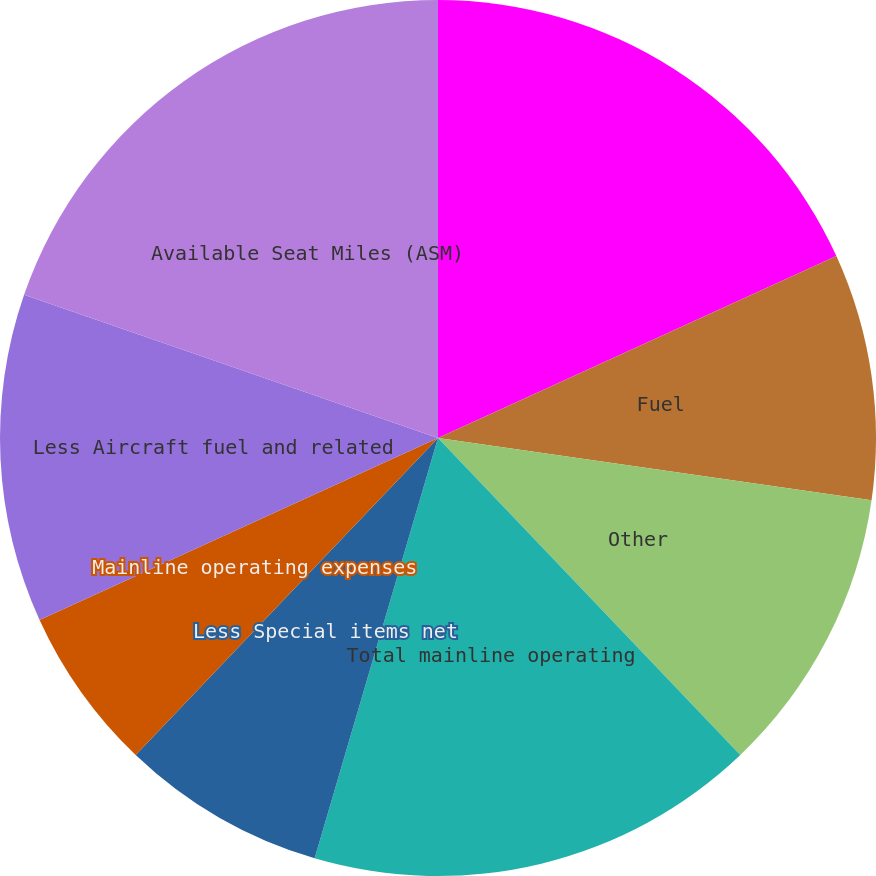Convert chart. <chart><loc_0><loc_0><loc_500><loc_500><pie_chart><fcel>Total operating expenses<fcel>Fuel<fcel>Other<fcel>Total mainline operating<fcel>Less Special items net<fcel>Mainline operating expenses<fcel>Less Aircraft fuel and related<fcel>Available Seat Miles (ASM)<nl><fcel>18.18%<fcel>9.09%<fcel>10.61%<fcel>16.67%<fcel>7.58%<fcel>6.06%<fcel>12.12%<fcel>19.7%<nl></chart> 